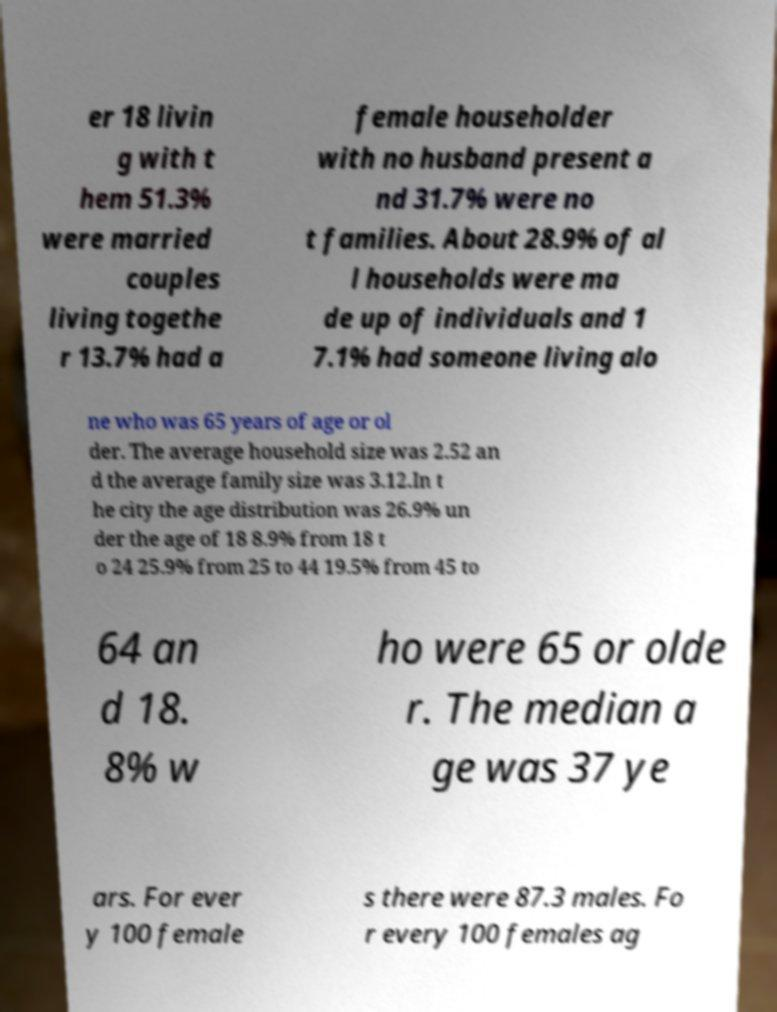What messages or text are displayed in this image? I need them in a readable, typed format. er 18 livin g with t hem 51.3% were married couples living togethe r 13.7% had a female householder with no husband present a nd 31.7% were no t families. About 28.9% of al l households were ma de up of individuals and 1 7.1% had someone living alo ne who was 65 years of age or ol der. The average household size was 2.52 an d the average family size was 3.12.In t he city the age distribution was 26.9% un der the age of 18 8.9% from 18 t o 24 25.9% from 25 to 44 19.5% from 45 to 64 an d 18. 8% w ho were 65 or olde r. The median a ge was 37 ye ars. For ever y 100 female s there were 87.3 males. Fo r every 100 females ag 